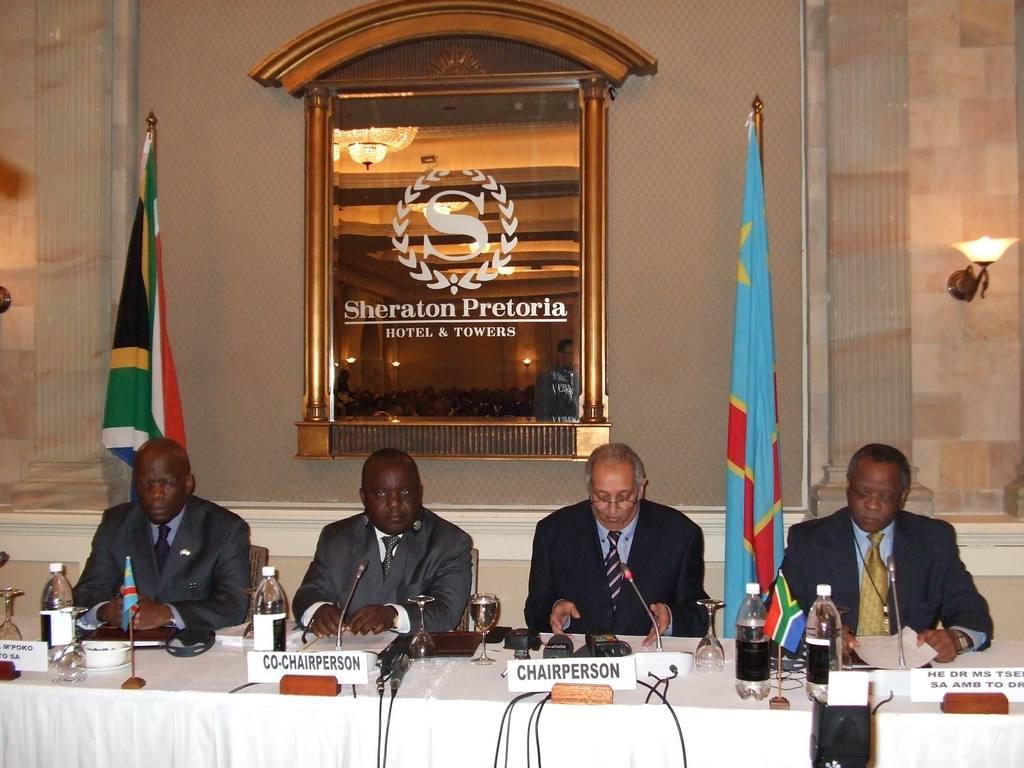How would you summarize this image in a sentence or two? In this image I can see four men are sitting on chairs. I can see they all are wearing shirt, tie and blazers. I can also see a table and on it I can see white colour tablecloth, few mics, few water bottles and I can see something is written at few places. In the background I can see few flags, a light and I can see something is written over here. 